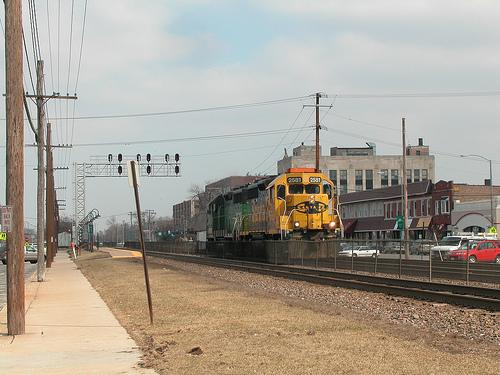What is the general mood of the area in the image? Describe the overall atmosphere. The entire area appears pretty dismal, with low light and a gloomy atmosphere. b) 2) Red car parked by the curb d) 4) White cement sidewalk 2) A small red car is parked by the curb 4) White cement sidewalk along the street In a product advertisement task, design a slogan mentioning the red car parked by the curb. "Stand out from the crowd with our strikingly red, compact cars – designed for style and comfort even in the most dismal surroundings." Identify the main mode of transportation present in the image. A yellow locomotive engine with the number 2531 on the front, pulling train cars on steel tracks. Identify any structures or barriers separating the train tracks from the surroundings. A chain link fence separates the train tracks from the surrounding area. For the multi-choice VQA task, choose the correct option: What is the color of the sidewalk along the street? c) White What type of sign is posted near the train tracks and what does it look like? There is a red and white street sign posted; it is leaning and has red letters on a white background. a) 3) Train signals on a support structure d) 4) White cement sidewalk along the street What color are the train cars that the locomotive engine is pulling? Describe any unique features. The train cars are black with green details. One of the cars is a green train car. Name any two objects hanging above the train tracks and provide their respective details. There's a traffic signal structure with train signals and a row of power lines above the tracks. Which vehicles are parked near the train tracks? Describe their colors and types. A small red car and a white van are parked near the train tracks; the red car is by the curb, and the van is next to it. 